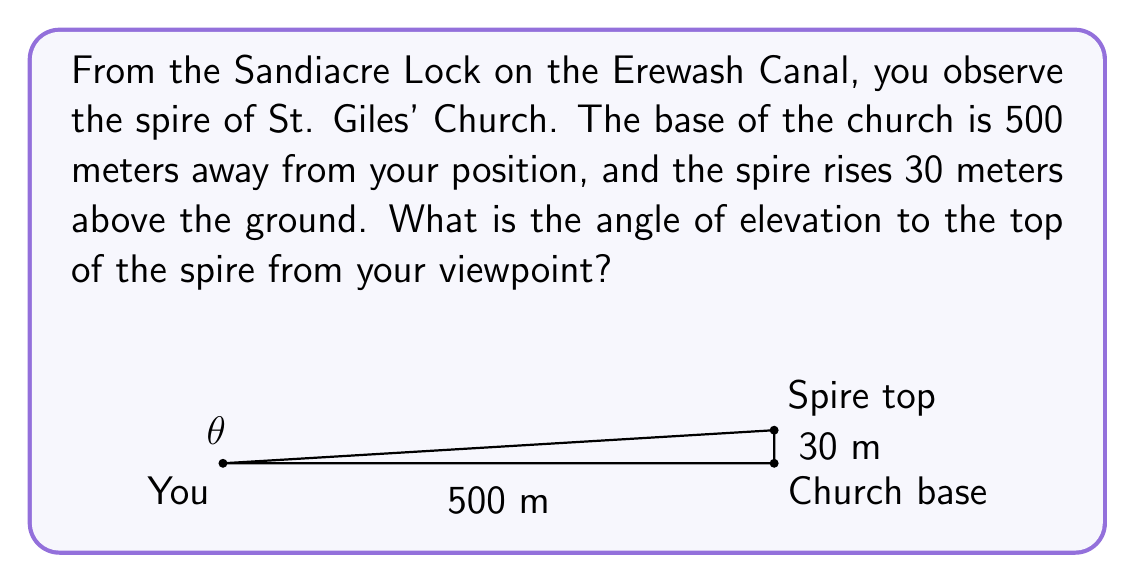Help me with this question. To solve this problem, we need to use trigonometry, specifically the tangent function. Let's break it down step-by-step:

1) In this scenario, we have a right-angled triangle. The base of the triangle is the distance from you to the church (500 m), and the height is the height of the spire (30 m).

2) The angle of elevation is the angle between the horizontal line of sight and the line of sight to the top of the spire. This is the angle we need to find.

3) In a right-angled triangle, tangent of an angle is the ratio of the opposite side to the adjacent side.

   $$ \tan(\theta) = \frac{\text{opposite}}{\text{adjacent}} $$

4) In our case:
   - The opposite side is the height of the spire (30 m)
   - The adjacent side is the distance to the church (500 m)

5) Let's plug these values into the tangent formula:

   $$ \tan(\theta) = \frac{30}{500} = 0.06 $$

6) To find the angle $\theta$, we need to use the inverse tangent (arctan or $\tan^{-1}$):

   $$ \theta = \tan^{-1}(0.06) $$

7) Using a calculator or trigonometric tables:

   $$ \theta \approx 3.43^\circ $$

Thus, the angle of elevation to the top of St. Giles' Church spire from the Sandiacre Lock is approximately 3.43 degrees.
Answer: $3.43^\circ$ (rounded to two decimal places) 